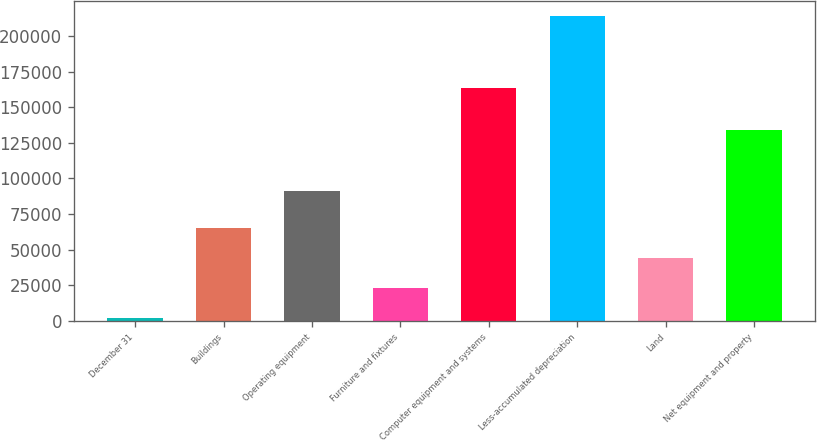Convert chart. <chart><loc_0><loc_0><loc_500><loc_500><bar_chart><fcel>December 31<fcel>Buildings<fcel>Operating equipment<fcel>Furniture and fixtures<fcel>Computer equipment and systems<fcel>Less-accumulated depreciation<fcel>Land<fcel>Net equipment and property<nl><fcel>2017<fcel>65554.6<fcel>91430<fcel>23196.2<fcel>163220<fcel>213809<fcel>44375.4<fcel>134088<nl></chart> 